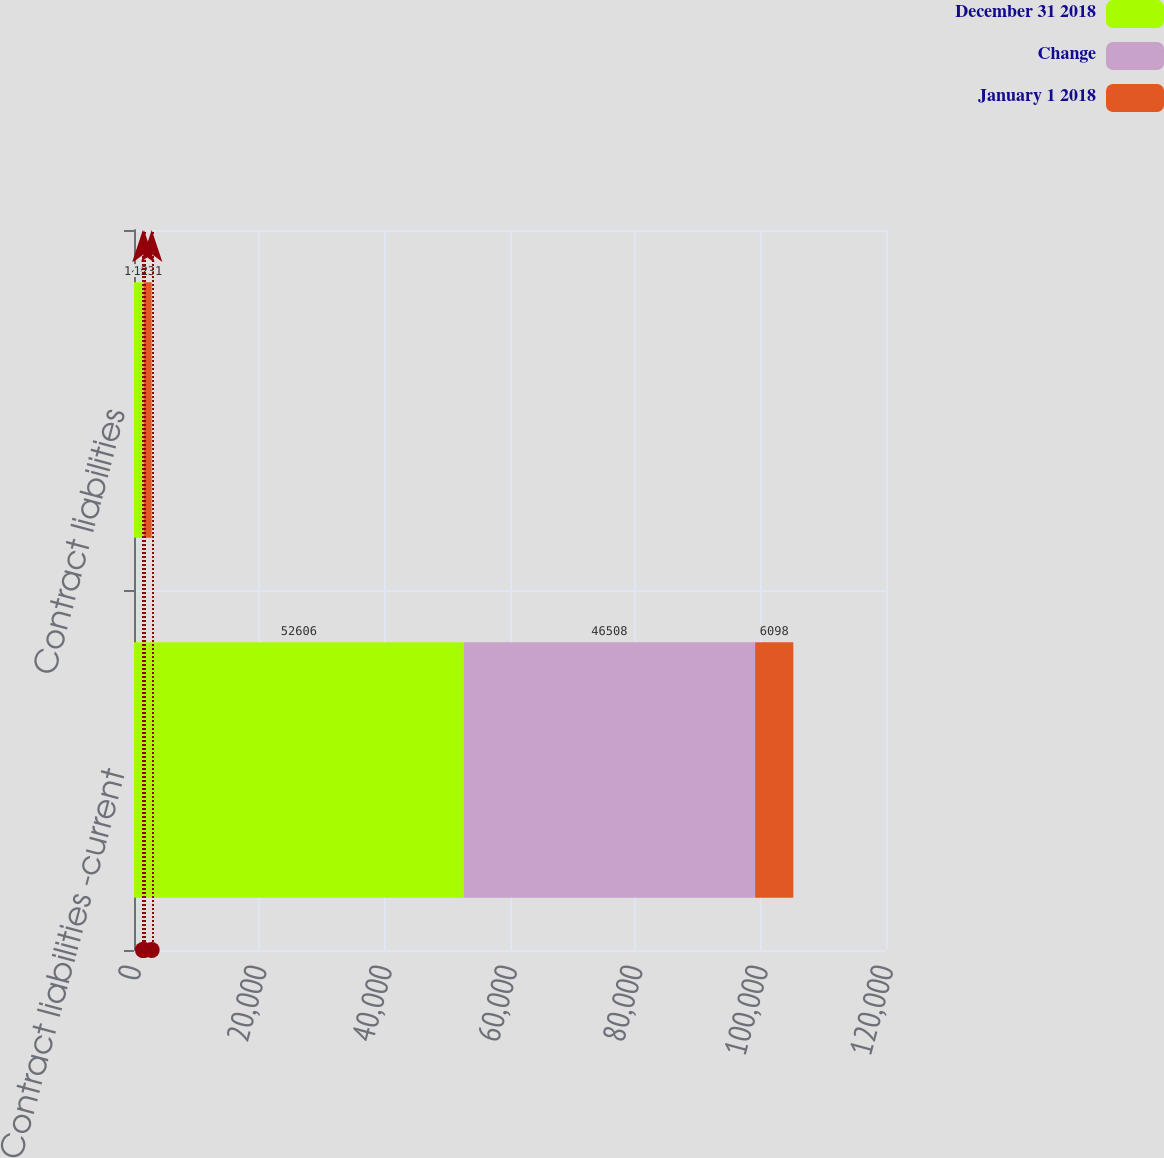Convert chart to OTSL. <chart><loc_0><loc_0><loc_500><loc_500><stacked_bar_chart><ecel><fcel>Contract liabilities -current<fcel>Contract liabilities<nl><fcel>December 31 2018<fcel>52606<fcel>1413<nl><fcel>Change<fcel>46508<fcel>182<nl><fcel>January 1 2018<fcel>6098<fcel>1231<nl></chart> 